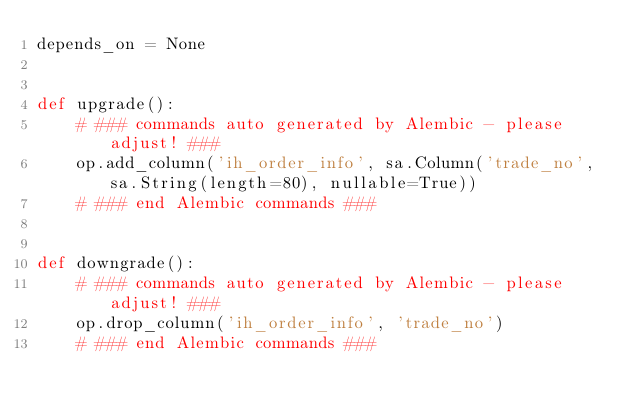Convert code to text. <code><loc_0><loc_0><loc_500><loc_500><_Python_>depends_on = None


def upgrade():
    # ### commands auto generated by Alembic - please adjust! ###
    op.add_column('ih_order_info', sa.Column('trade_no', sa.String(length=80), nullable=True))
    # ### end Alembic commands ###


def downgrade():
    # ### commands auto generated by Alembic - please adjust! ###
    op.drop_column('ih_order_info', 'trade_no')
    # ### end Alembic commands ###
</code> 